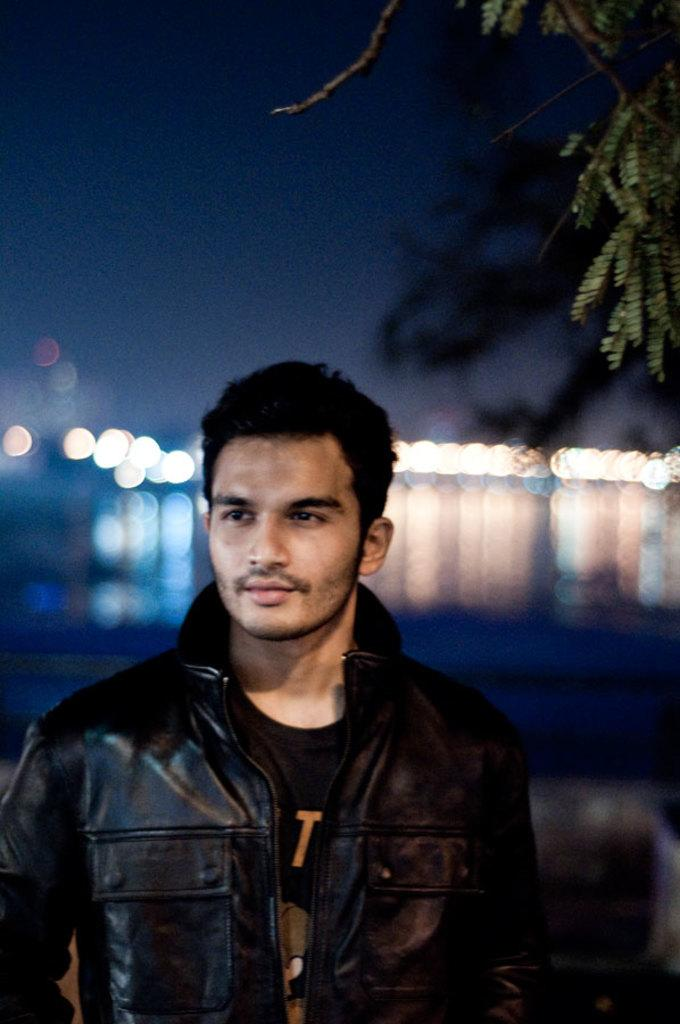Who is present in the image? There is a man in the image. What is the man wearing? The man is wearing a black jacket. What can be seen in the background of the image? There is water in the background of the image. What is located to the right of the image? There is a tree to the right of the image. What is visible at the top of the image? The sky is visible at the top of the image. What type of machine can be seen in the man's eyes in the image? There is no machine visible in the man's eyes in the image. 